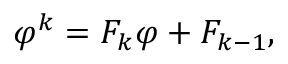Convert formula to latex. <formula><loc_0><loc_0><loc_500><loc_500>\varphi ^ { k } = F _ { k } \varphi + F _ { k - 1 } ,</formula> 